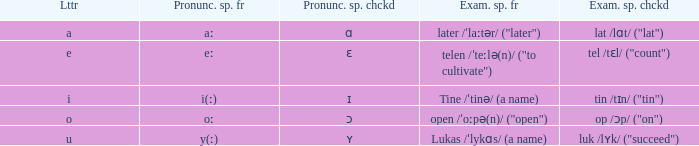What is Pronunciation Spelled Checked, when Example Spelled Checked is "tin /tɪn/ ("tin")" Ɪ. 